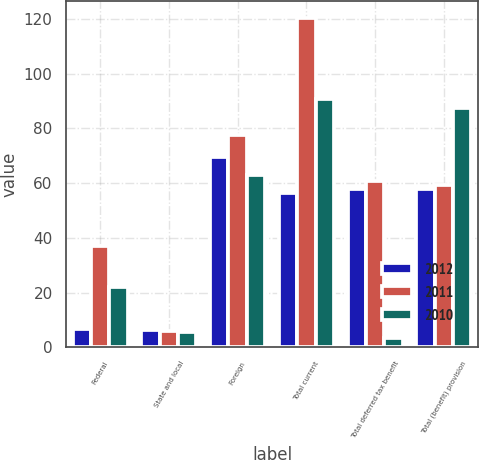<chart> <loc_0><loc_0><loc_500><loc_500><stacked_bar_chart><ecel><fcel>Federal<fcel>State and local<fcel>Foreign<fcel>Total current<fcel>Total deferred tax benefit<fcel>Total (benefit) provision<nl><fcel>2012<fcel>6.8<fcel>6.2<fcel>69.5<fcel>56.5<fcel>58<fcel>58<nl><fcel>2011<fcel>37<fcel>5.9<fcel>77.5<fcel>120.4<fcel>60.9<fcel>59.5<nl><fcel>2010<fcel>22.1<fcel>5.6<fcel>63.1<fcel>90.8<fcel>3.3<fcel>87.5<nl></chart> 